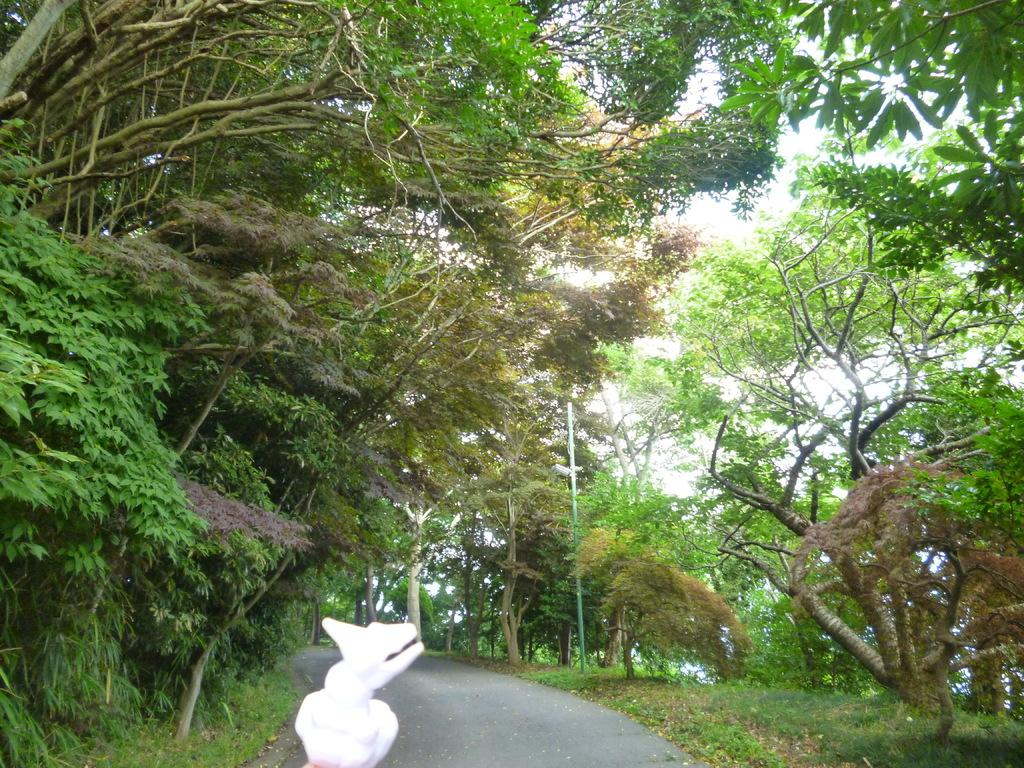What is the main subject of the image? There is a doll in the image. What color is the doll? The doll is white in color. What can be seen in the background of the image? There are trees in the background of the image. What type of club can be seen in the image? There is no club present in the image; it features a doll and trees in the background. What flavor of flame is depicted in the image? There is no flame present in the image, and therefore no flavor can be determined. 